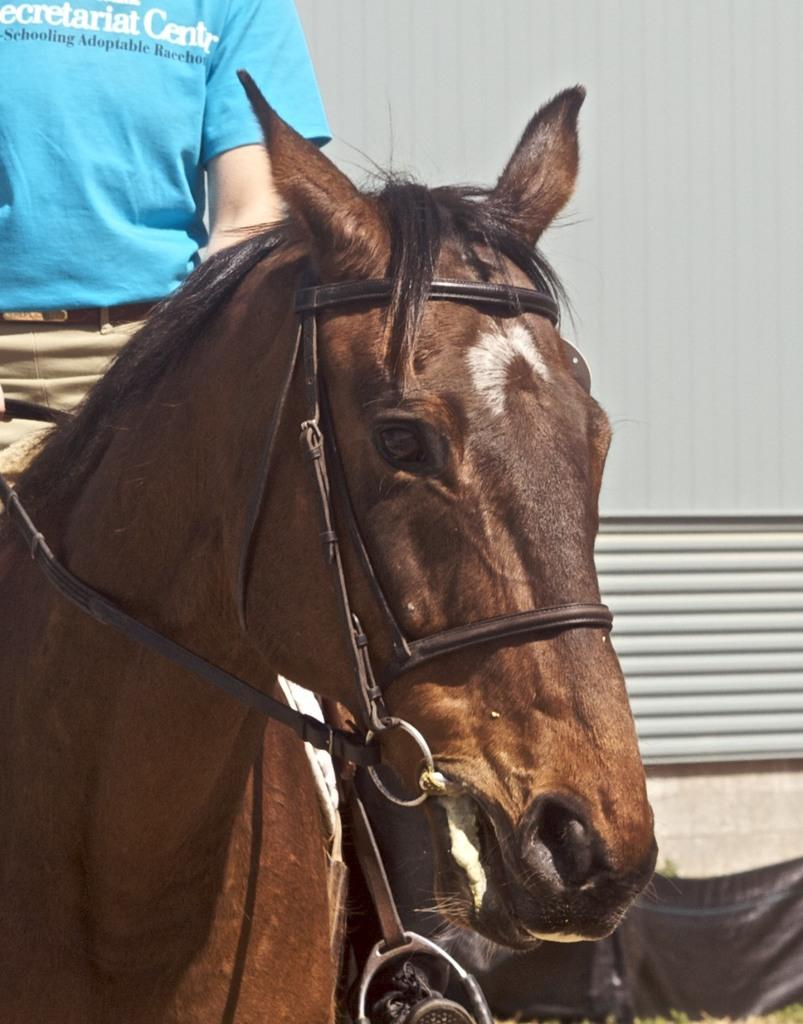What is the main subject of the image? There is a person in the image. What is the person wearing? The person is wearing a blue t-shirt. What is the person doing in the image? The person is riding a horse. Where is the horse located in the image? The horse is on the left side of the image. What can be seen on the right side of the image? There is a wall on the right side of the image. What is the black object at the bottom of the image? It is not specified what the black object is, but it is present at the bottom of the image. Can you see a bridge connecting two sides of the ocean in the image? There is no bridge or ocean present in the image. What type of toad is sitting on the person's shoulder in the image? There is no toad present in the image. 